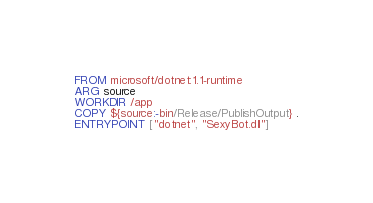Convert code to text. <code><loc_0><loc_0><loc_500><loc_500><_Dockerfile_>FROM microsoft/dotnet:1.1-runtime
ARG source
WORKDIR /app
COPY ${source:-bin/Release/PublishOutput} .
ENTRYPOINT ["dotnet", "SexyBot.dll"]
</code> 